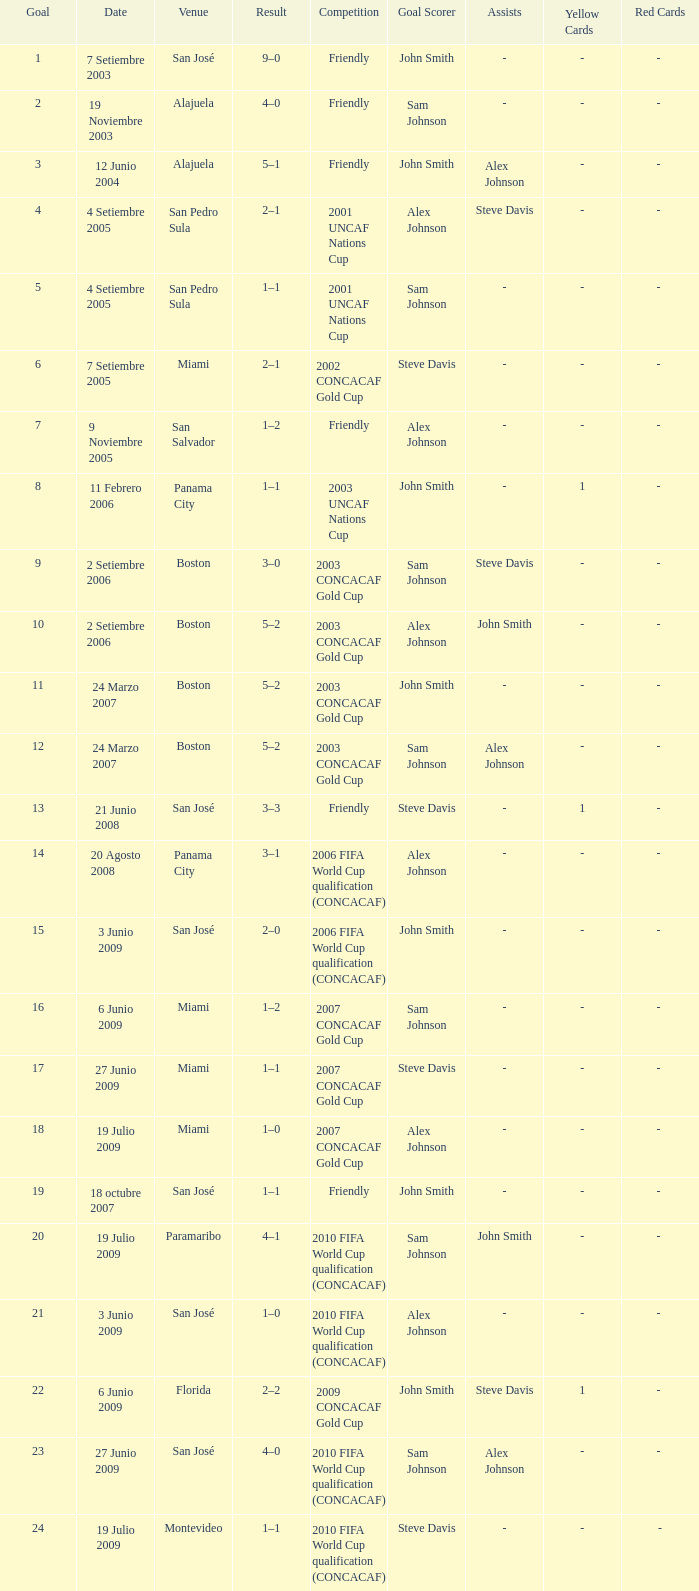How many goals were scored on 21 Junio 2008? 1.0. 